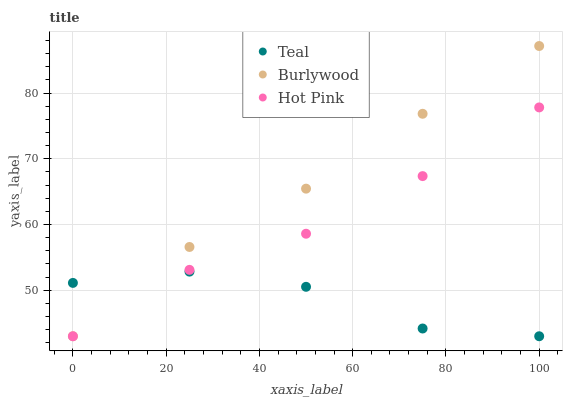Does Teal have the minimum area under the curve?
Answer yes or no. Yes. Does Burlywood have the maximum area under the curve?
Answer yes or no. Yes. Does Hot Pink have the minimum area under the curve?
Answer yes or no. No. Does Hot Pink have the maximum area under the curve?
Answer yes or no. No. Is Burlywood the smoothest?
Answer yes or no. Yes. Is Teal the roughest?
Answer yes or no. Yes. Is Hot Pink the smoothest?
Answer yes or no. No. Is Hot Pink the roughest?
Answer yes or no. No. Does Burlywood have the lowest value?
Answer yes or no. Yes. Does Burlywood have the highest value?
Answer yes or no. Yes. Does Hot Pink have the highest value?
Answer yes or no. No. Does Teal intersect Burlywood?
Answer yes or no. Yes. Is Teal less than Burlywood?
Answer yes or no. No. Is Teal greater than Burlywood?
Answer yes or no. No. 